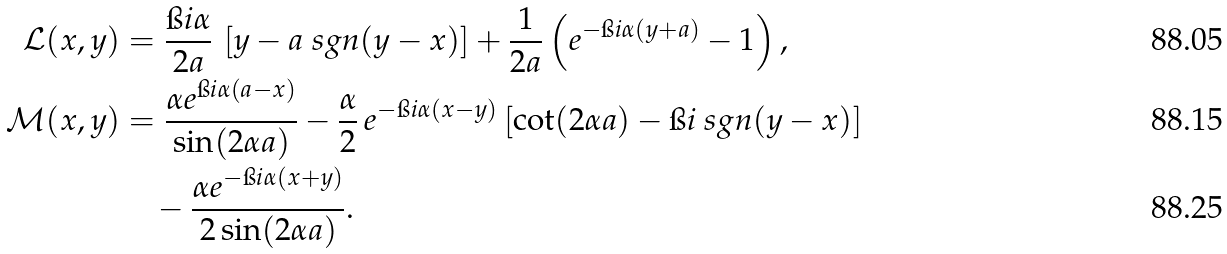Convert formula to latex. <formula><loc_0><loc_0><loc_500><loc_500>\mathcal { L } ( x , y ) & = \frac { \i i \alpha } { 2 a } \, \left [ y - a \ s g n ( y - x ) \right ] + \frac { 1 } { 2 a } \left ( e ^ { - \i i \alpha ( y + a ) } - 1 \right ) , \\ \mathcal { M } ( x , y ) & = \frac { \alpha e ^ { \i i \alpha ( a - x ) } } { \sin ( 2 \alpha a ) } - \frac { \alpha } { 2 } \, e ^ { - \i i \alpha ( x - y ) } \left [ \cot ( 2 \alpha a ) - \i i \ s g n ( y - x ) \right ] \\ & \quad - \frac { \alpha e ^ { - \i i \alpha ( x + y ) } } { 2 \sin ( 2 \alpha a ) } .</formula> 